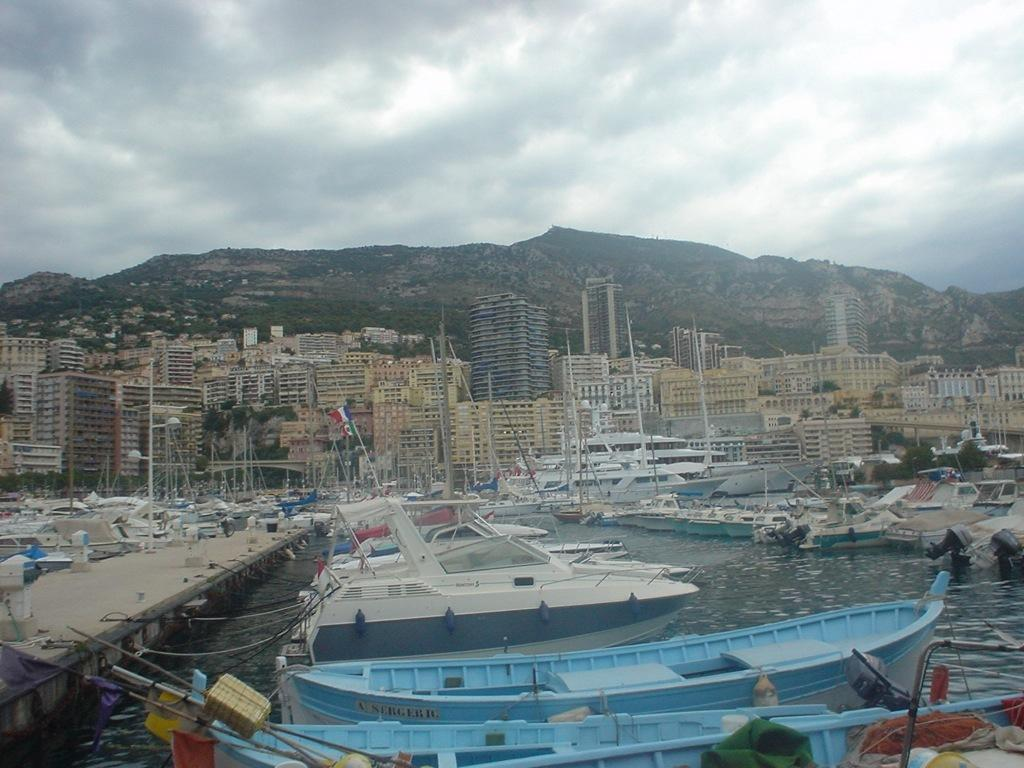What can be seen at the bottom of the image? There are boats, water, and a bridge at the bottom of the image. What is located in the middle of the image? There are buildings, boats, flags, hills, trees, and sky visible in the middle of the image. Can you describe the sky in the image? The sky is visible in the middle of the image, and there are clouds present. How many eyes can be seen on the boats in the image? There are no eyes present on the boats in the image. What type of bait is being used by the boats in the middle of the image? There is no indication of fishing or bait in the image; the boats are simply depicted in the water. 